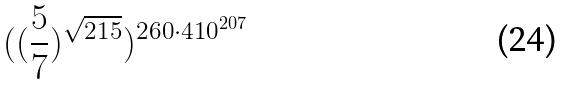Convert formula to latex. <formula><loc_0><loc_0><loc_500><loc_500>( ( \frac { 5 } { 7 } ) ^ { \sqrt { 2 1 5 } } ) ^ { 2 6 0 \cdot 4 1 0 ^ { 2 0 7 } }</formula> 